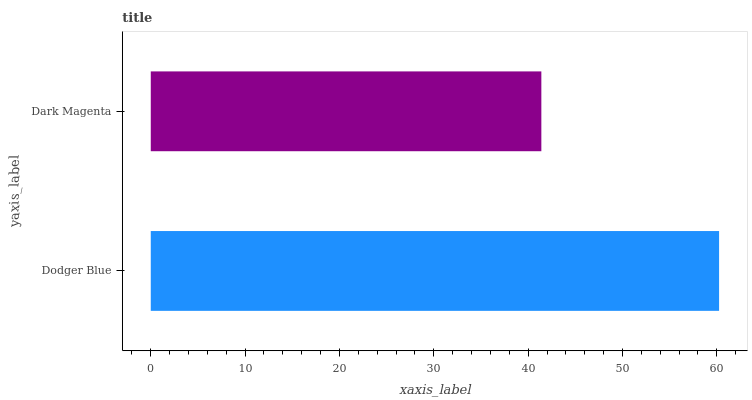Is Dark Magenta the minimum?
Answer yes or no. Yes. Is Dodger Blue the maximum?
Answer yes or no. Yes. Is Dark Magenta the maximum?
Answer yes or no. No. Is Dodger Blue greater than Dark Magenta?
Answer yes or no. Yes. Is Dark Magenta less than Dodger Blue?
Answer yes or no. Yes. Is Dark Magenta greater than Dodger Blue?
Answer yes or no. No. Is Dodger Blue less than Dark Magenta?
Answer yes or no. No. Is Dodger Blue the high median?
Answer yes or no. Yes. Is Dark Magenta the low median?
Answer yes or no. Yes. Is Dark Magenta the high median?
Answer yes or no. No. Is Dodger Blue the low median?
Answer yes or no. No. 